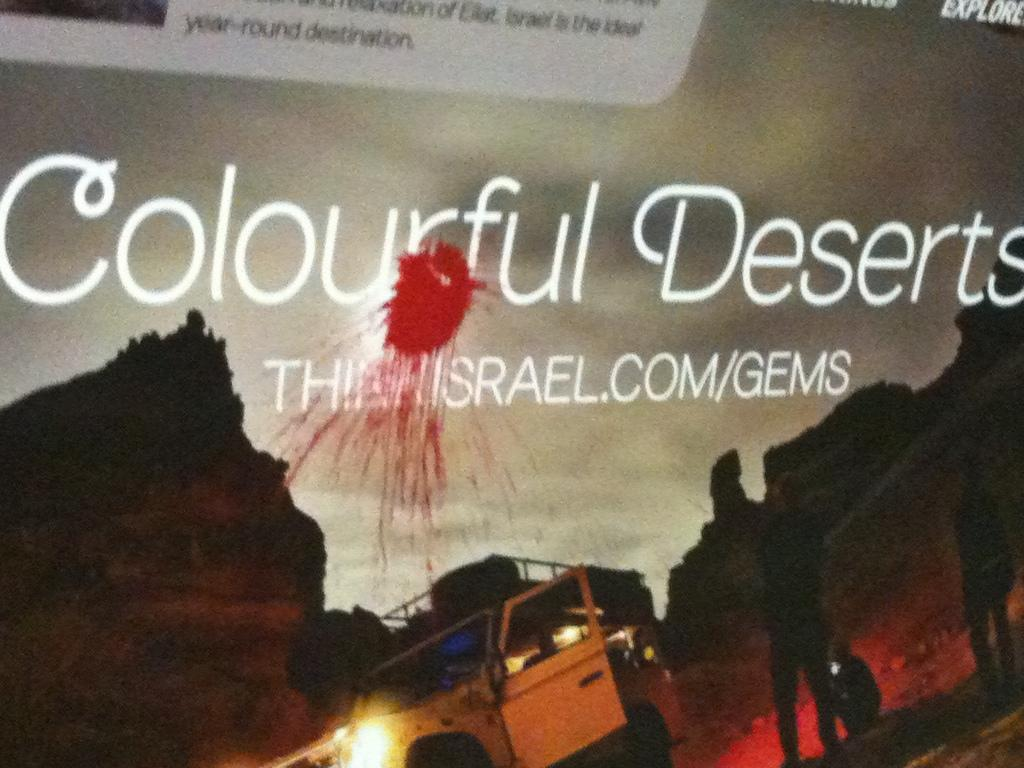<image>
Summarize the visual content of the image. A poster entitled Colourful Deserts has blood like splatter on it. 